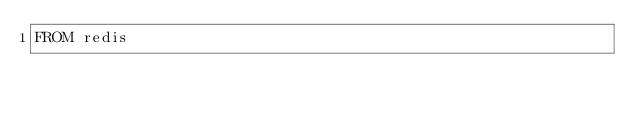Convert code to text. <code><loc_0><loc_0><loc_500><loc_500><_Dockerfile_>FROM redis</code> 